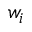Convert formula to latex. <formula><loc_0><loc_0><loc_500><loc_500>w _ { i }</formula> 